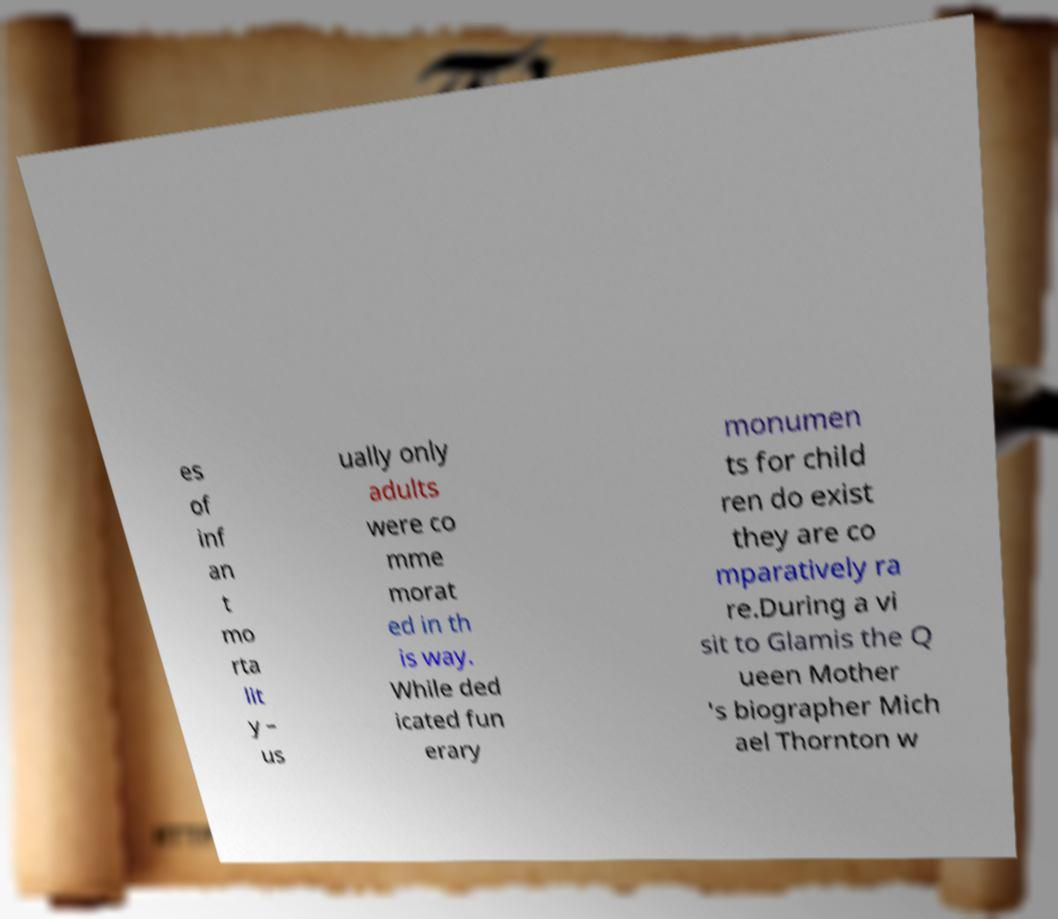Please read and relay the text visible in this image. What does it say? es of inf an t mo rta lit y – us ually only adults were co mme morat ed in th is way. While ded icated fun erary monumen ts for child ren do exist they are co mparatively ra re.During a vi sit to Glamis the Q ueen Mother 's biographer Mich ael Thornton w 